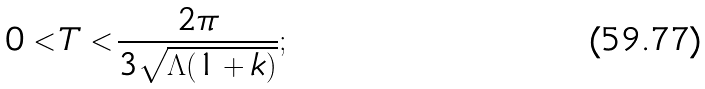<formula> <loc_0><loc_0><loc_500><loc_500>0 < T < \frac { 2 \pi } { 3 \sqrt { \Lambda ( 1 + k ) } } ;</formula> 